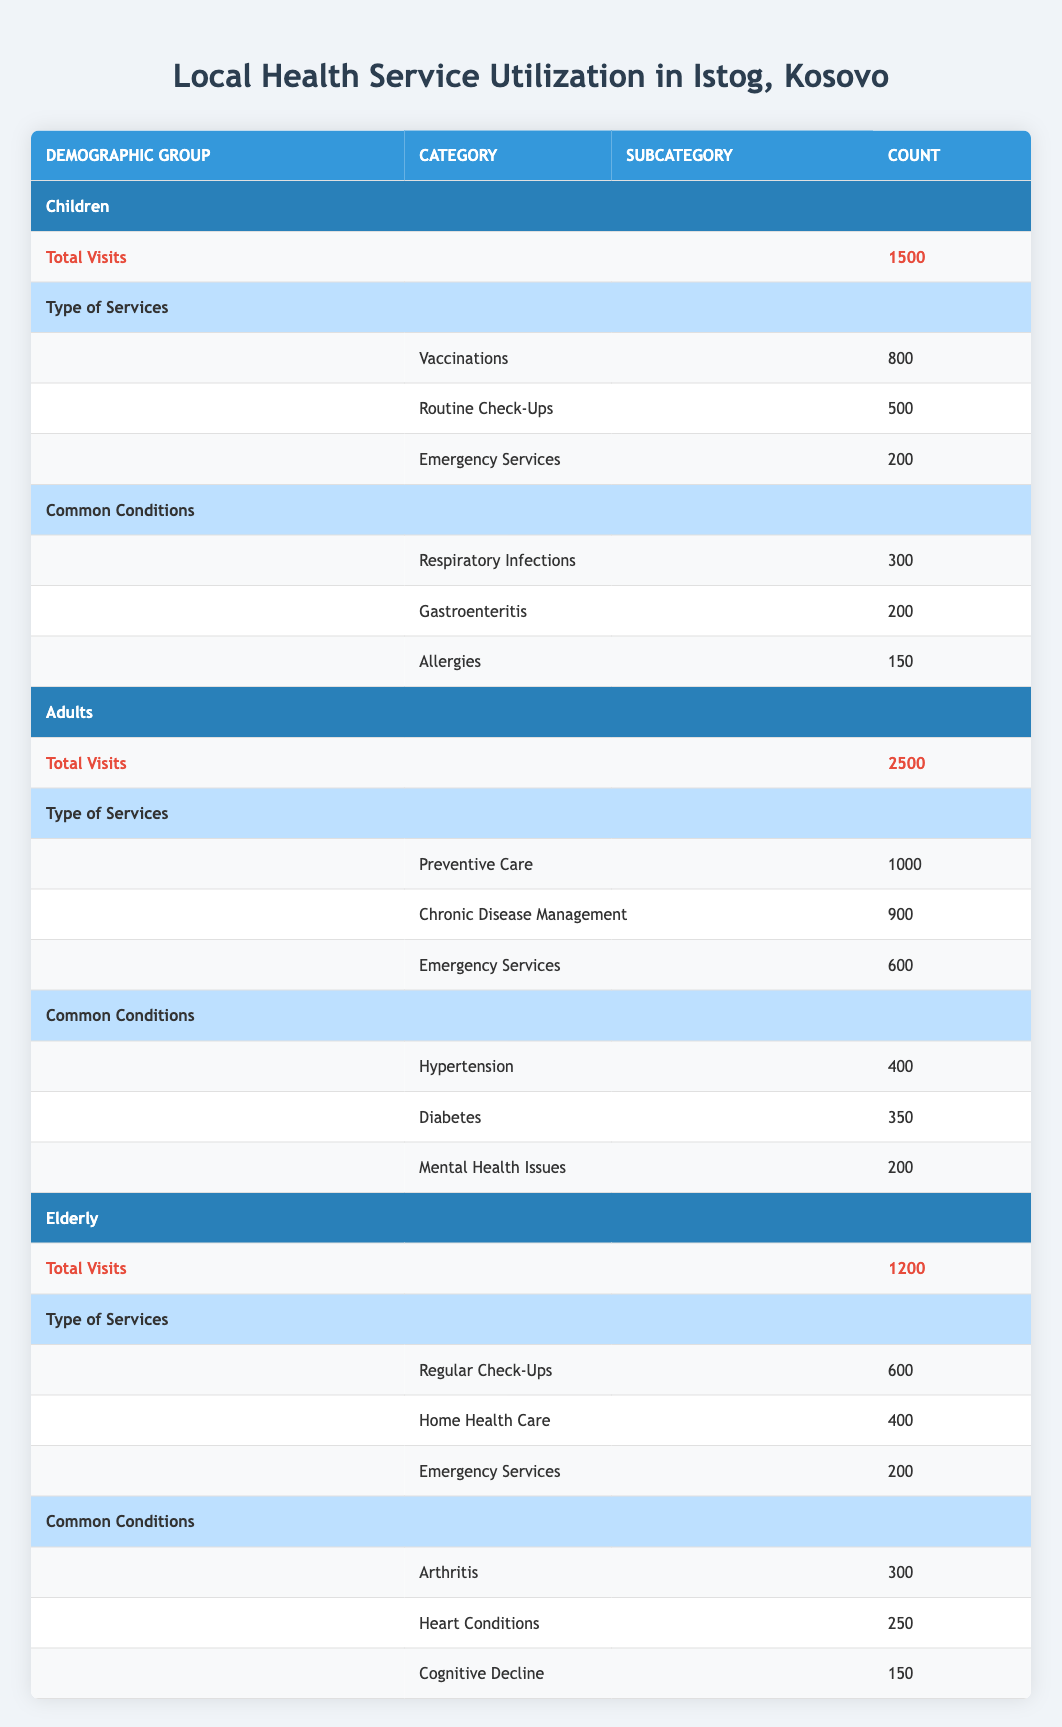What's the total number of visits for children in Istog? The table shows a row under the "Children" demographic group labeled "Total Visits," which indicates that there were 1500 visits.
Answer: 1500 What is the most common condition for adults using local health services? In the "Adults" section under "Common Conditions," the highest count is for "Hypertension" with 400 visits.
Answer: Hypertension How many more visits were made by adults compared to the elderly? The total visits for adults is 2500, while for the elderly it is 1200. Therefore, the difference is 2500 - 1200 = 1300.
Answer: 1300 Did children utilize more Emergency Services than the elderly? The "Emergency Services" visit count for children is 200 and for the elderly is also 200. Since both counts are equal, the answer is no.
Answer: No What percentage of total visits for adults were for Preventive Care? The total visits for adults is 2500, and the number of Preventive Care visits is 1000. The percentage is calculated as (1000/2500) * 100 = 40%.
Answer: 40% Which demographic group has the highest number of visits for Routine Check-Ups? The "Routine Check-Ups" service is only listed under the "Children" demographic group with 500 visits, which is higher than the other groups.
Answer: Children What is the total number of visits for common conditions in the elderly demographic? For the "Elderly" group, the total visits for common conditions are the sum of Arthritis (300), Heart Conditions (250), and Cognitive Decline (150), which totals to 300 + 250 + 150 = 700.
Answer: 700 Are there more total visits for vaccinations than for chronic disease management? Total visits for vaccinations is 800 (under Children) and for chronic disease management is 900 (under Adults). Since 800 is less than 900, the answer is no.
Answer: No What is the total number of Emergency Service visits for all groups combined? The Emergency Service visits for Children is 200, for Adults is 600, and for Elderly is 200. Adding these gives a total of 200 + 600 + 200 = 1000.
Answer: 1000 